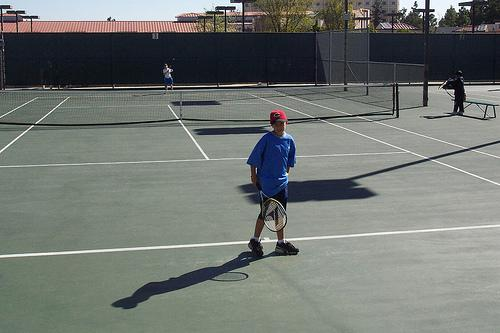Question: how many people are in the picture?
Choices:
A. Three.
B. Two.
C. One.
D. None.
Answer with the letter. Answer: A Question: what are they doing?
Choices:
A. Talking on the phone.
B. Playing tennis.
C. Running.
D. Smoking a cigar.
Answer with the letter. Answer: B Question: where are the people?
Choices:
A. On a tennis court.
B. In the park.
C. At a party.
D. At a picnic.
Answer with the letter. Answer: A Question: what color is the boy's cap?
Choices:
A. Blue.
B. Black.
C. Red.
D. White.
Answer with the letter. Answer: C Question: what is in the boy's hand?
Choices:
A. A soda.
B. A ball.
C. Tennis racket.
D. His shoes.
Answer with the letter. Answer: C Question: why is the boy looking away from the tennis court?
Choices:
A. Posing for the picture.
B. Looking at the street.
C. Yelling at someone.
D. Someone caught his attention.
Answer with the letter. Answer: A 